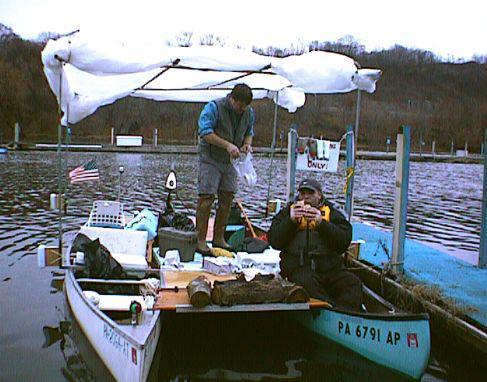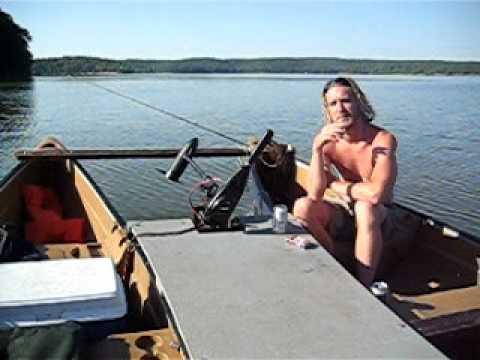The first image is the image on the left, the second image is the image on the right. Considering the images on both sides, is "In each image, one or more persons is shown with a double canoe that is built with a solid flat platform between the two canoes." valid? Answer yes or no. Yes. The first image is the image on the left, the second image is the image on the right. For the images displayed, is the sentence "There are at least half a dozen people in the boats." factually correct? Answer yes or no. No. 